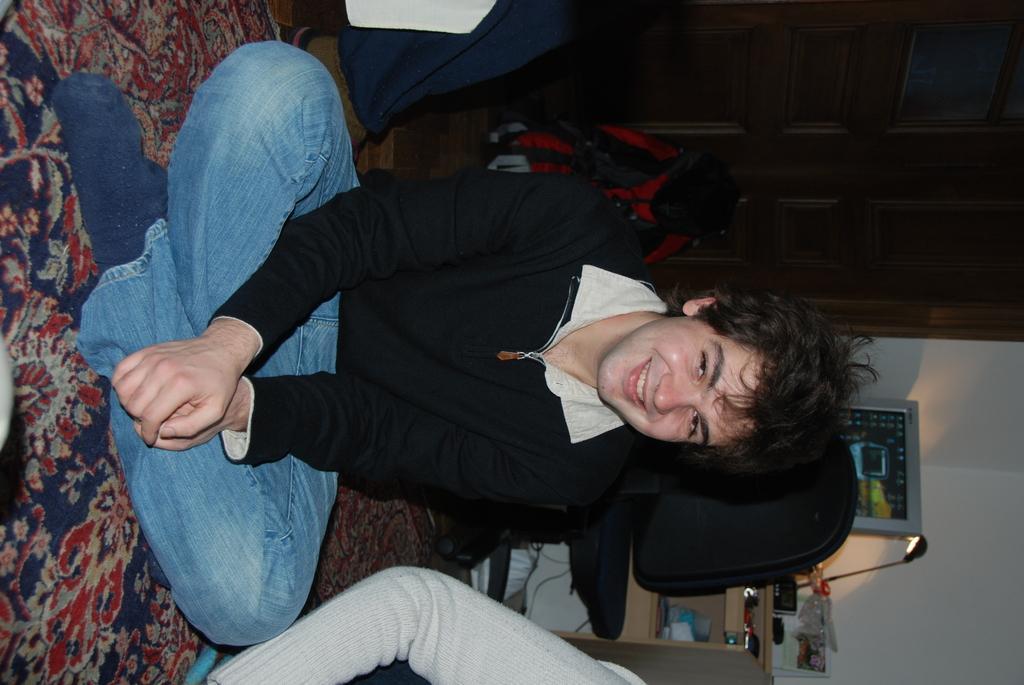Please provide a concise description of this image. It is a tilted image, there is a man sitting on the floor on the carpet and he is smiling and looking towards his left. Behind the man there is a table and in front of the table there is a chair, on the table there is a lamp, a desktop and many other things were kept. Behind the table there is a wall and on the either side of the man there are two other people and they are not clearly visible in the picture. 